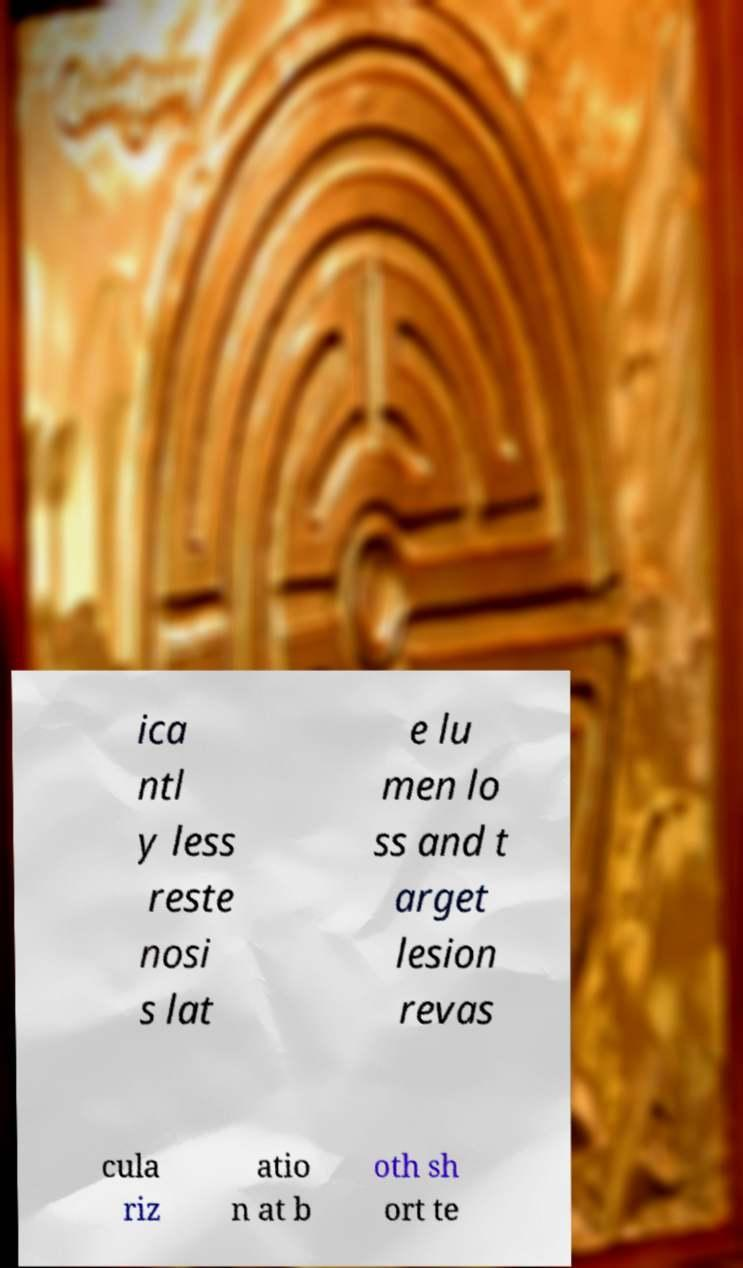Can you accurately transcribe the text from the provided image for me? ica ntl y less reste nosi s lat e lu men lo ss and t arget lesion revas cula riz atio n at b oth sh ort te 